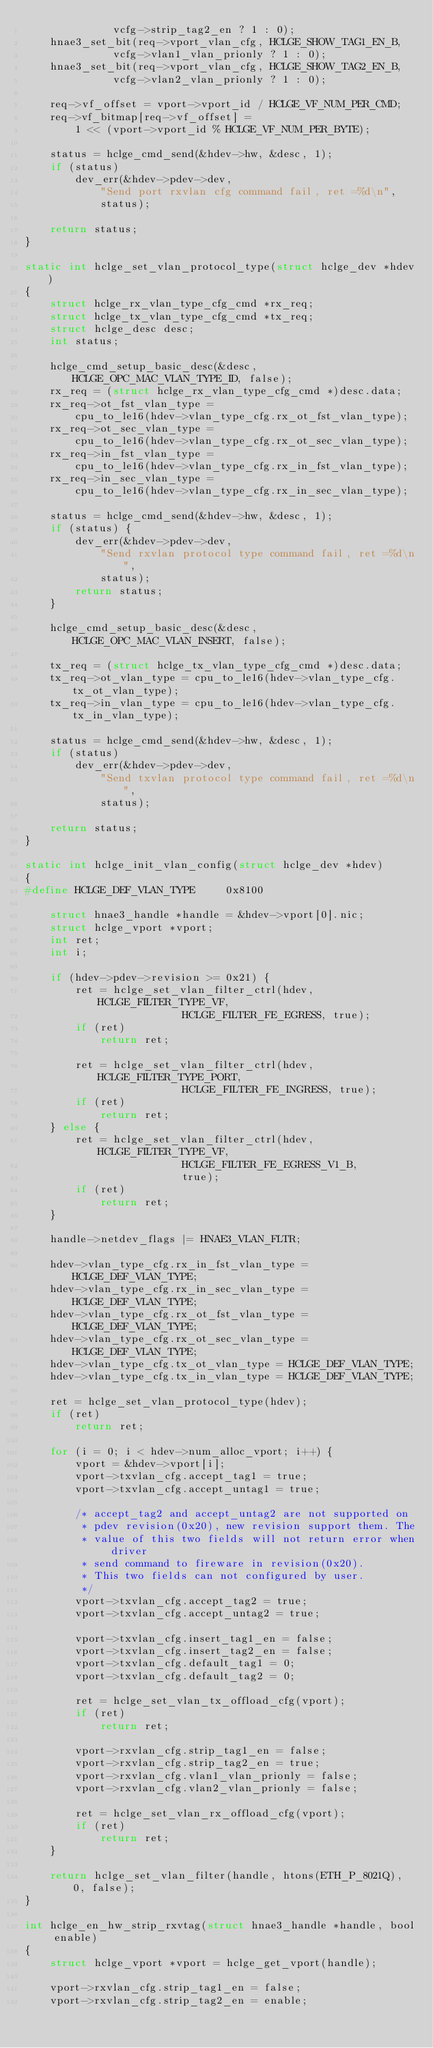<code> <loc_0><loc_0><loc_500><loc_500><_C_>		      vcfg->strip_tag2_en ? 1 : 0);
	hnae3_set_bit(req->vport_vlan_cfg, HCLGE_SHOW_TAG1_EN_B,
		      vcfg->vlan1_vlan_prionly ? 1 : 0);
	hnae3_set_bit(req->vport_vlan_cfg, HCLGE_SHOW_TAG2_EN_B,
		      vcfg->vlan2_vlan_prionly ? 1 : 0);

	req->vf_offset = vport->vport_id / HCLGE_VF_NUM_PER_CMD;
	req->vf_bitmap[req->vf_offset] =
		1 << (vport->vport_id % HCLGE_VF_NUM_PER_BYTE);

	status = hclge_cmd_send(&hdev->hw, &desc, 1);
	if (status)
		dev_err(&hdev->pdev->dev,
			"Send port rxvlan cfg command fail, ret =%d\n",
			status);

	return status;
}

static int hclge_set_vlan_protocol_type(struct hclge_dev *hdev)
{
	struct hclge_rx_vlan_type_cfg_cmd *rx_req;
	struct hclge_tx_vlan_type_cfg_cmd *tx_req;
	struct hclge_desc desc;
	int status;

	hclge_cmd_setup_basic_desc(&desc, HCLGE_OPC_MAC_VLAN_TYPE_ID, false);
	rx_req = (struct hclge_rx_vlan_type_cfg_cmd *)desc.data;
	rx_req->ot_fst_vlan_type =
		cpu_to_le16(hdev->vlan_type_cfg.rx_ot_fst_vlan_type);
	rx_req->ot_sec_vlan_type =
		cpu_to_le16(hdev->vlan_type_cfg.rx_ot_sec_vlan_type);
	rx_req->in_fst_vlan_type =
		cpu_to_le16(hdev->vlan_type_cfg.rx_in_fst_vlan_type);
	rx_req->in_sec_vlan_type =
		cpu_to_le16(hdev->vlan_type_cfg.rx_in_sec_vlan_type);

	status = hclge_cmd_send(&hdev->hw, &desc, 1);
	if (status) {
		dev_err(&hdev->pdev->dev,
			"Send rxvlan protocol type command fail, ret =%d\n",
			status);
		return status;
	}

	hclge_cmd_setup_basic_desc(&desc, HCLGE_OPC_MAC_VLAN_INSERT, false);

	tx_req = (struct hclge_tx_vlan_type_cfg_cmd *)desc.data;
	tx_req->ot_vlan_type = cpu_to_le16(hdev->vlan_type_cfg.tx_ot_vlan_type);
	tx_req->in_vlan_type = cpu_to_le16(hdev->vlan_type_cfg.tx_in_vlan_type);

	status = hclge_cmd_send(&hdev->hw, &desc, 1);
	if (status)
		dev_err(&hdev->pdev->dev,
			"Send txvlan protocol type command fail, ret =%d\n",
			status);

	return status;
}

static int hclge_init_vlan_config(struct hclge_dev *hdev)
{
#define HCLGE_DEF_VLAN_TYPE		0x8100

	struct hnae3_handle *handle = &hdev->vport[0].nic;
	struct hclge_vport *vport;
	int ret;
	int i;

	if (hdev->pdev->revision >= 0x21) {
		ret = hclge_set_vlan_filter_ctrl(hdev, HCLGE_FILTER_TYPE_VF,
						 HCLGE_FILTER_FE_EGRESS, true);
		if (ret)
			return ret;

		ret = hclge_set_vlan_filter_ctrl(hdev, HCLGE_FILTER_TYPE_PORT,
						 HCLGE_FILTER_FE_INGRESS, true);
		if (ret)
			return ret;
	} else {
		ret = hclge_set_vlan_filter_ctrl(hdev, HCLGE_FILTER_TYPE_VF,
						 HCLGE_FILTER_FE_EGRESS_V1_B,
						 true);
		if (ret)
			return ret;
	}

	handle->netdev_flags |= HNAE3_VLAN_FLTR;

	hdev->vlan_type_cfg.rx_in_fst_vlan_type = HCLGE_DEF_VLAN_TYPE;
	hdev->vlan_type_cfg.rx_in_sec_vlan_type = HCLGE_DEF_VLAN_TYPE;
	hdev->vlan_type_cfg.rx_ot_fst_vlan_type = HCLGE_DEF_VLAN_TYPE;
	hdev->vlan_type_cfg.rx_ot_sec_vlan_type = HCLGE_DEF_VLAN_TYPE;
	hdev->vlan_type_cfg.tx_ot_vlan_type = HCLGE_DEF_VLAN_TYPE;
	hdev->vlan_type_cfg.tx_in_vlan_type = HCLGE_DEF_VLAN_TYPE;

	ret = hclge_set_vlan_protocol_type(hdev);
	if (ret)
		return ret;

	for (i = 0; i < hdev->num_alloc_vport; i++) {
		vport = &hdev->vport[i];
		vport->txvlan_cfg.accept_tag1 = true;
		vport->txvlan_cfg.accept_untag1 = true;

		/* accept_tag2 and accept_untag2 are not supported on
		 * pdev revision(0x20), new revision support them. The
		 * value of this two fields will not return error when driver
		 * send command to fireware in revision(0x20).
		 * This two fields can not configured by user.
		 */
		vport->txvlan_cfg.accept_tag2 = true;
		vport->txvlan_cfg.accept_untag2 = true;

		vport->txvlan_cfg.insert_tag1_en = false;
		vport->txvlan_cfg.insert_tag2_en = false;
		vport->txvlan_cfg.default_tag1 = 0;
		vport->txvlan_cfg.default_tag2 = 0;

		ret = hclge_set_vlan_tx_offload_cfg(vport);
		if (ret)
			return ret;

		vport->rxvlan_cfg.strip_tag1_en = false;
		vport->rxvlan_cfg.strip_tag2_en = true;
		vport->rxvlan_cfg.vlan1_vlan_prionly = false;
		vport->rxvlan_cfg.vlan2_vlan_prionly = false;

		ret = hclge_set_vlan_rx_offload_cfg(vport);
		if (ret)
			return ret;
	}

	return hclge_set_vlan_filter(handle, htons(ETH_P_8021Q), 0, false);
}

int hclge_en_hw_strip_rxvtag(struct hnae3_handle *handle, bool enable)
{
	struct hclge_vport *vport = hclge_get_vport(handle);

	vport->rxvlan_cfg.strip_tag1_en = false;
	vport->rxvlan_cfg.strip_tag2_en = enable;</code> 